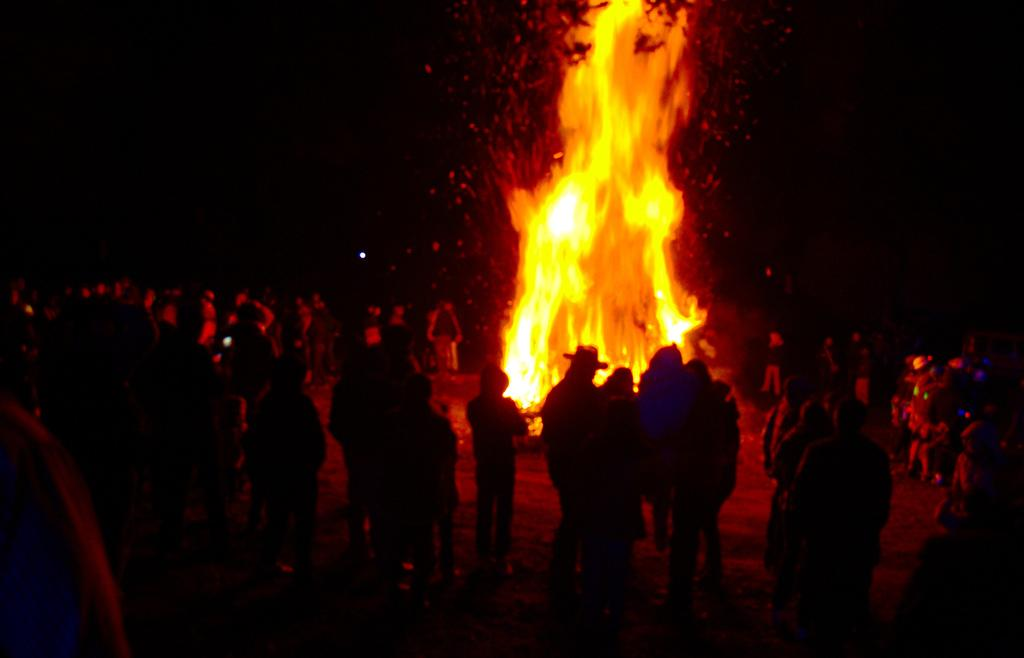How many people are in the image? There is a group of people standing in the image, but the exact number cannot be determined from the provided facts. What are the people in the image doing? The provided facts do not specify what the people are doing. What can be seen in the background of the image? There is a fire in the background of the image. What type of key is being used to open the letters in the image? There are no keys or letters present in the image, so this question cannot be answered. 